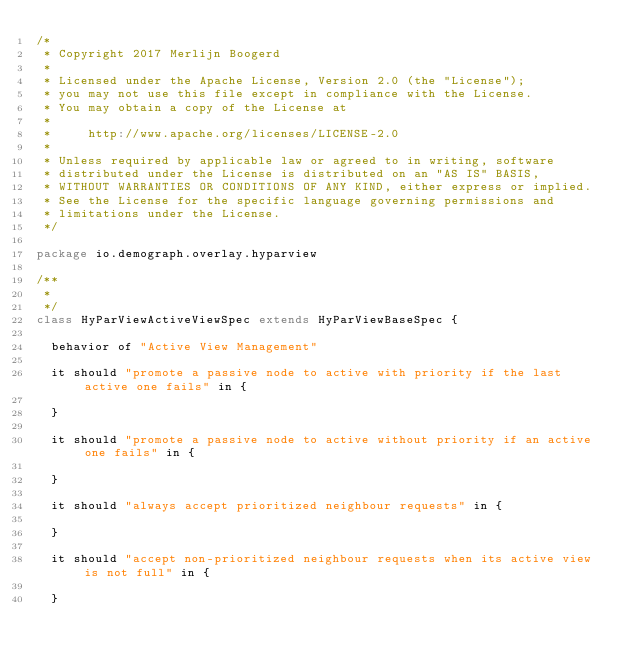Convert code to text. <code><loc_0><loc_0><loc_500><loc_500><_Scala_>/*
 * Copyright 2017 Merlijn Boogerd
 *
 * Licensed under the Apache License, Version 2.0 (the "License");
 * you may not use this file except in compliance with the License.
 * You may obtain a copy of the License at
 *
 *     http://www.apache.org/licenses/LICENSE-2.0
 *
 * Unless required by applicable law or agreed to in writing, software
 * distributed under the License is distributed on an "AS IS" BASIS,
 * WITHOUT WARRANTIES OR CONDITIONS OF ANY KIND, either express or implied.
 * See the License for the specific language governing permissions and
 * limitations under the License.
 */

package io.demograph.overlay.hyparview

/**
 *
 */
class HyParViewActiveViewSpec extends HyParViewBaseSpec {

  behavior of "Active View Management"

  it should "promote a passive node to active with priority if the last active one fails" in {

  }

  it should "promote a passive node to active without priority if an active one fails" in {

  }

  it should "always accept prioritized neighbour requests" in {

  }

  it should "accept non-prioritized neighbour requests when its active view is not full" in {

  }
</code> 